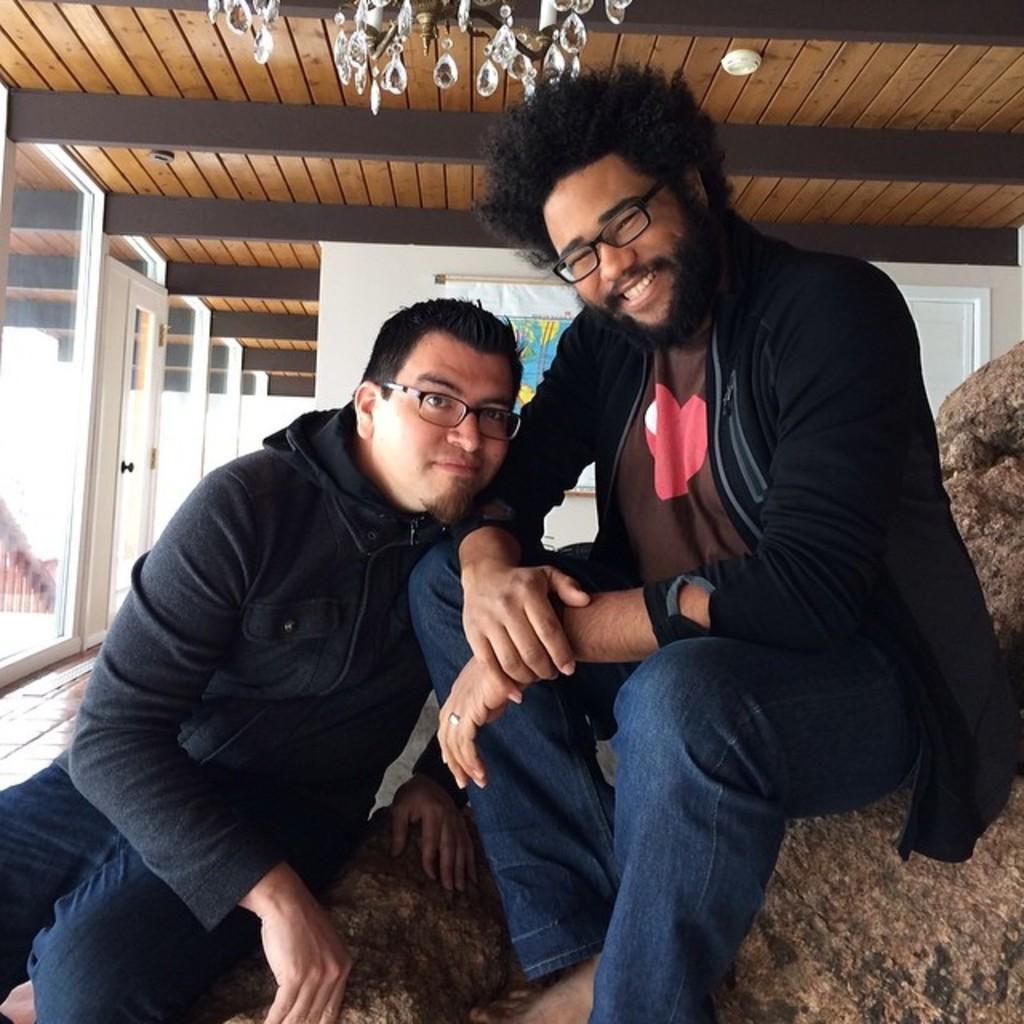Can you describe this image briefly? In this picture we can see two men wore spectacles and sitting and smiling and in the background we can see doors, banner, wall. 